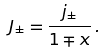<formula> <loc_0><loc_0><loc_500><loc_500>J _ { \pm } = \frac { j _ { \pm } } { 1 \mp x } \, .</formula> 